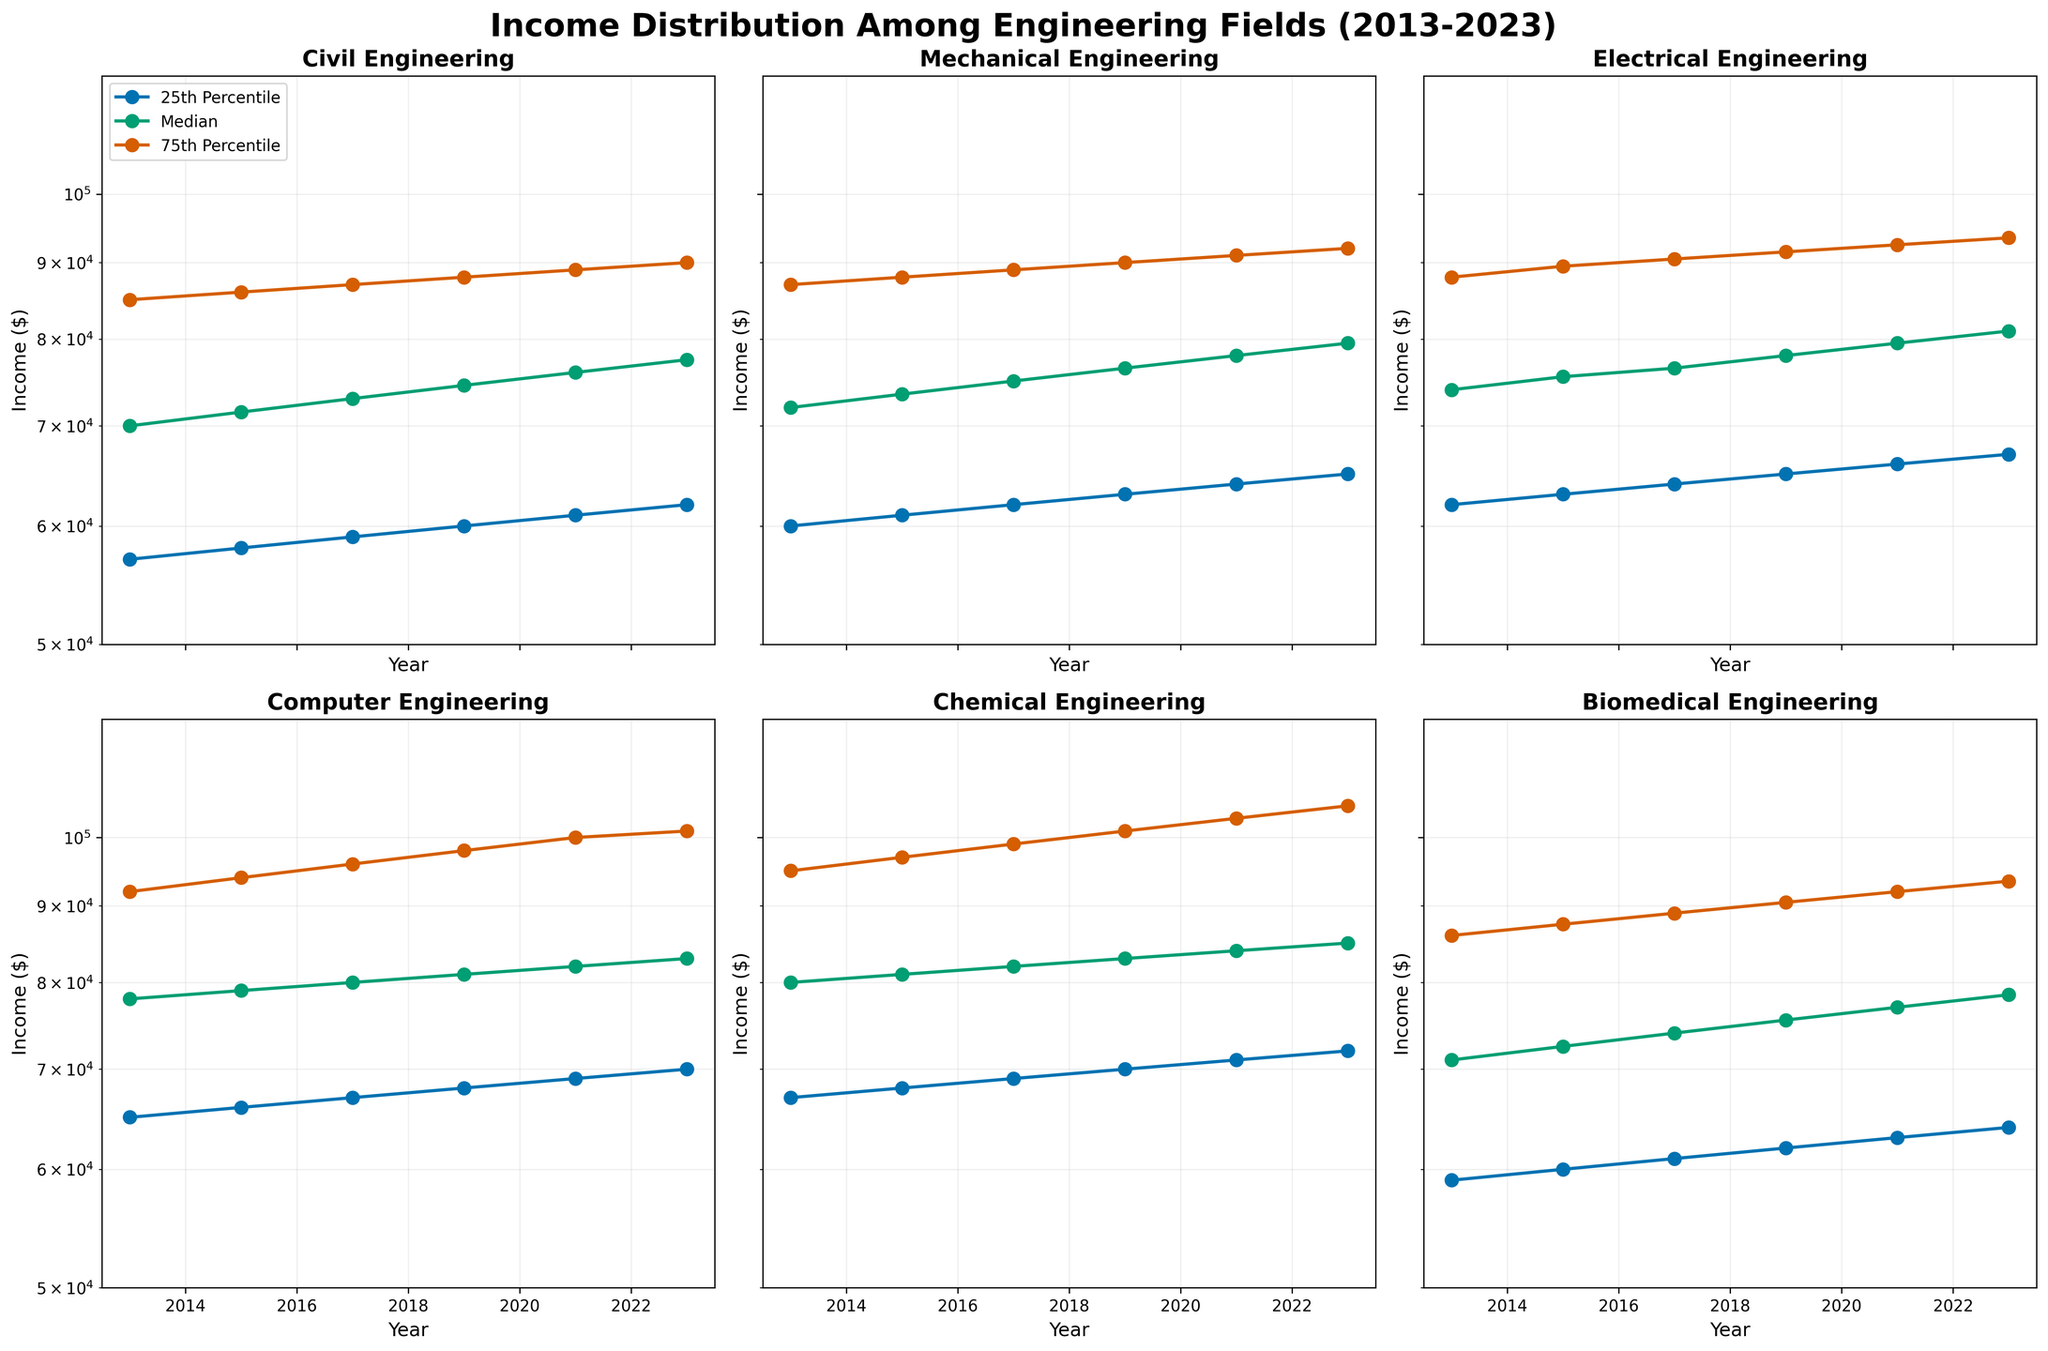What's the title of the figure? The title of the figure is displayed at the top and typically summarizes the primary content. In this case, it states that the plot shows income distribution among various engineering fields over the last decade.
Answer: Income Distribution Among Engineering Fields (2013-2023) What are the different engineering fields shown in the subplots? Each of the subplots represents a different engineering discipline. By listing the titles of each subplot, we can identify the fields.
Answer: Civil Engineering, Mechanical Engineering, Electrical Engineering, Computer Engineering, Chemical Engineering, Biomedical Engineering Which field had the highest 75th percentile income in 2023? By examining the 75th percentile data for all fields in 2023, we can see which field has the highest income. The corresponding subplot and specific line for 75th percentile in 2023 will provide this information.
Answer: Chemical Engineering Did the median income for Computer Engineering increase or decrease from 2013 to 2023? By following the median line (usually marked clearly and consistently across the subplot for Computer Engineering), we compare the median value for 2013 and 2023 to determine the trend.
Answer: Increase Compare the 25th percentile income of Biomedical Engineering to that of Mechanical Engineering in 2021. Which is higher? We need to look at the subplot for 2021 and compare the 25th percentile lines (often marked or color-coded similarly across subplots) for Biomedical Engineering and Mechanical Engineering.
Answer: Mechanical Engineering What is the income range between the 25th and 75th percentiles for Electrical Engineering in 2017? First, identify the 25th and 75th percentile values for Electrical Engineering in 2017. Then compute the difference between these values to get the income range.
Answer: 26,500 Of the fields shown, which had the steepest increase in median income between 2013 and 2023? For each field, calculate the difference in median income between 2013 and 2023. The field with the largest difference has the steepest increase.
Answer: Computer Engineering In which year did Chemical Engineering see a significant jump in the 75th percentile income, and what was the approximate change? Scan through the Chemical Engineering subplot's 75th percentile line and find the year with the largest jump. Measure the approximate income change between two consecutive data points.
Answer: 2017, about 30,500 Which field showed the least variation in 25th percentile income over the entire period? For each field, compute the range (maximum minus minimum) of the 25th percentile income across all years. The field with the smallest range has the least variation.
Answer: Biomedical Engineering In 2019, was the median income for Mechanical Engineering higher or lower than Electrical Engineering? Compare the median income value in 2019 for both Mechanical and Electrical Engineering subplots. Determine which one is higher.
Answer: Lower 